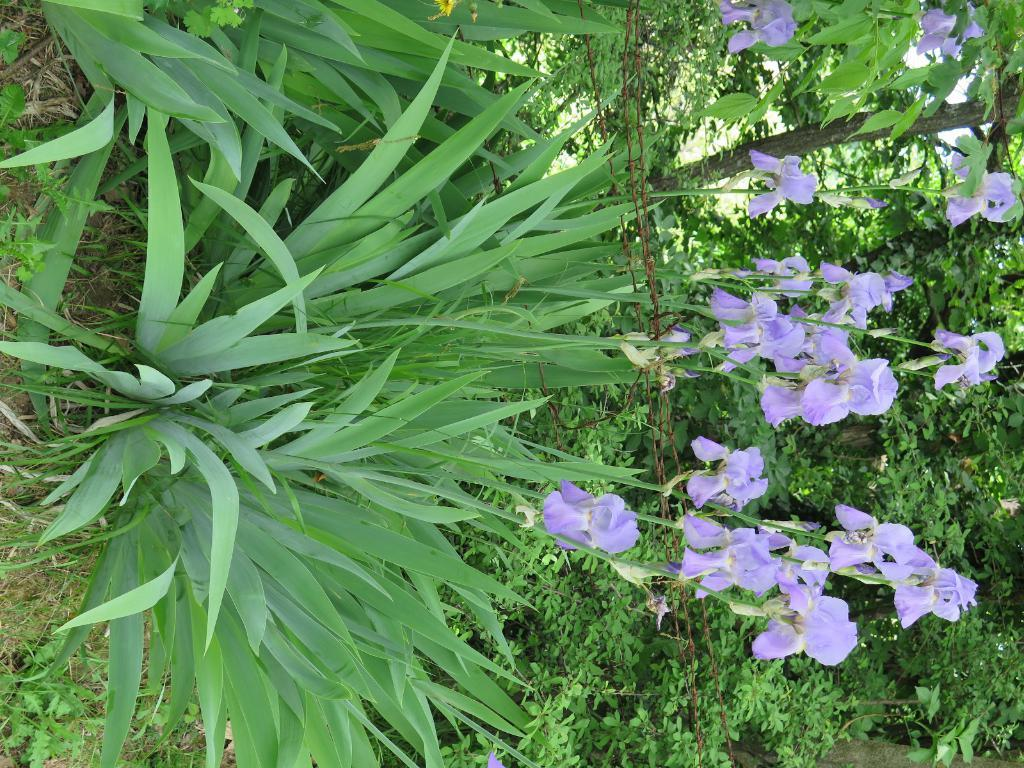What types of living organisms can be seen in the image? Plants and flowers are visible in the image. Can you describe the flowers in the image? The flowers in the image are part of the plants and add color and beauty to the scene. What type of harmony can be heard in the image? There is no audible harmony in the image, as it is a still image featuring plants and flowers. 